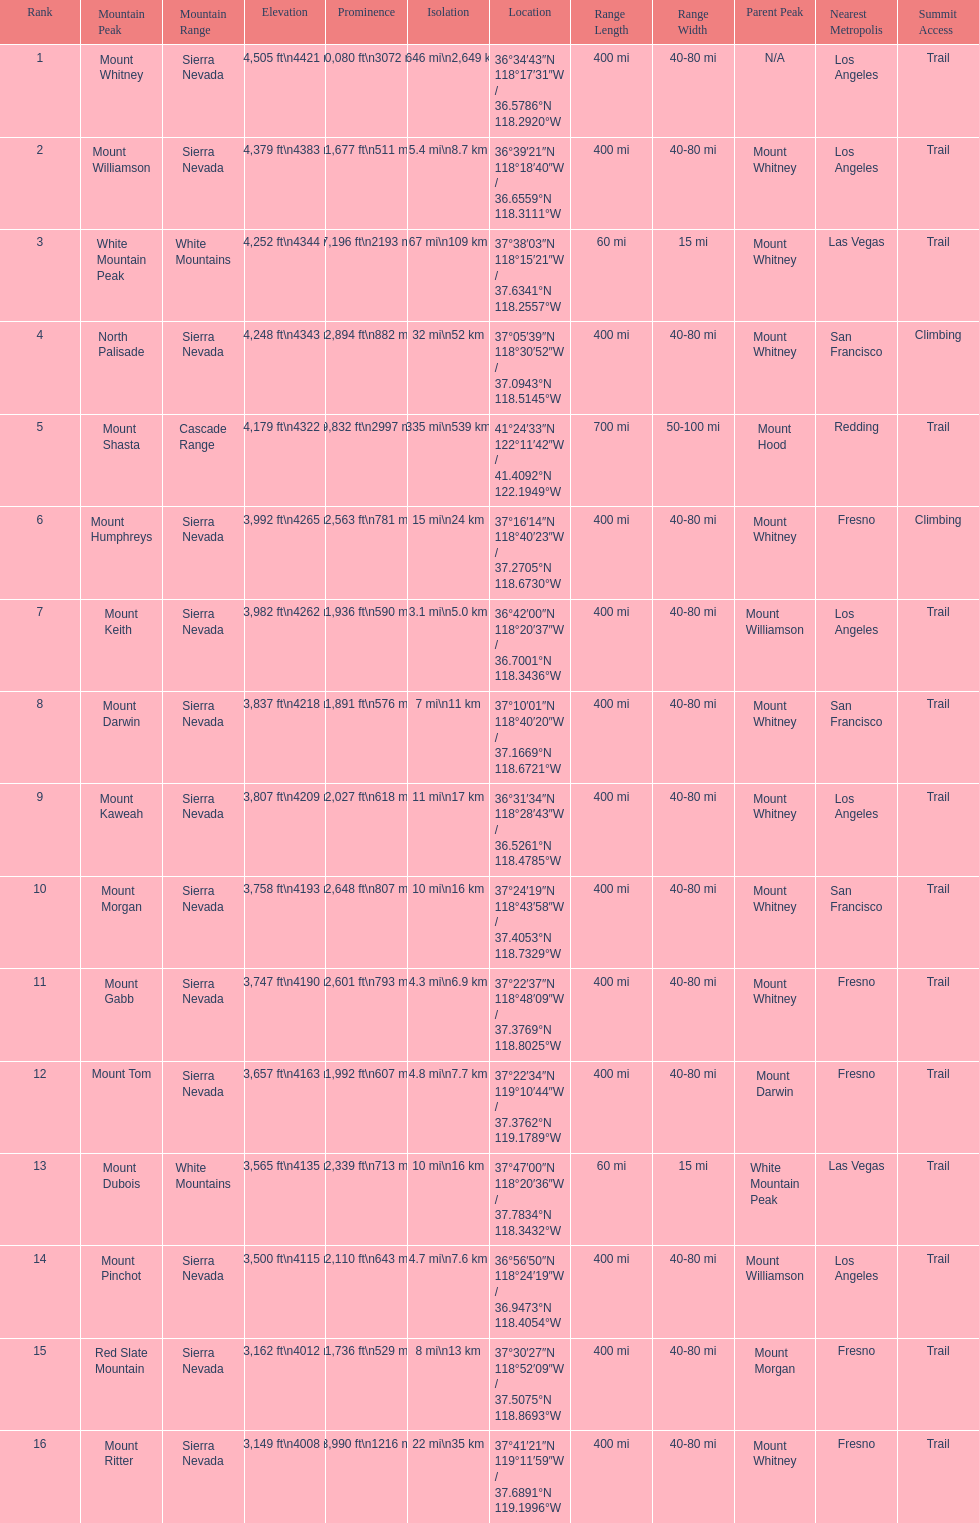In feet, what is the difference between the tallest peak and the 9th tallest peak in california? 698 ft. 